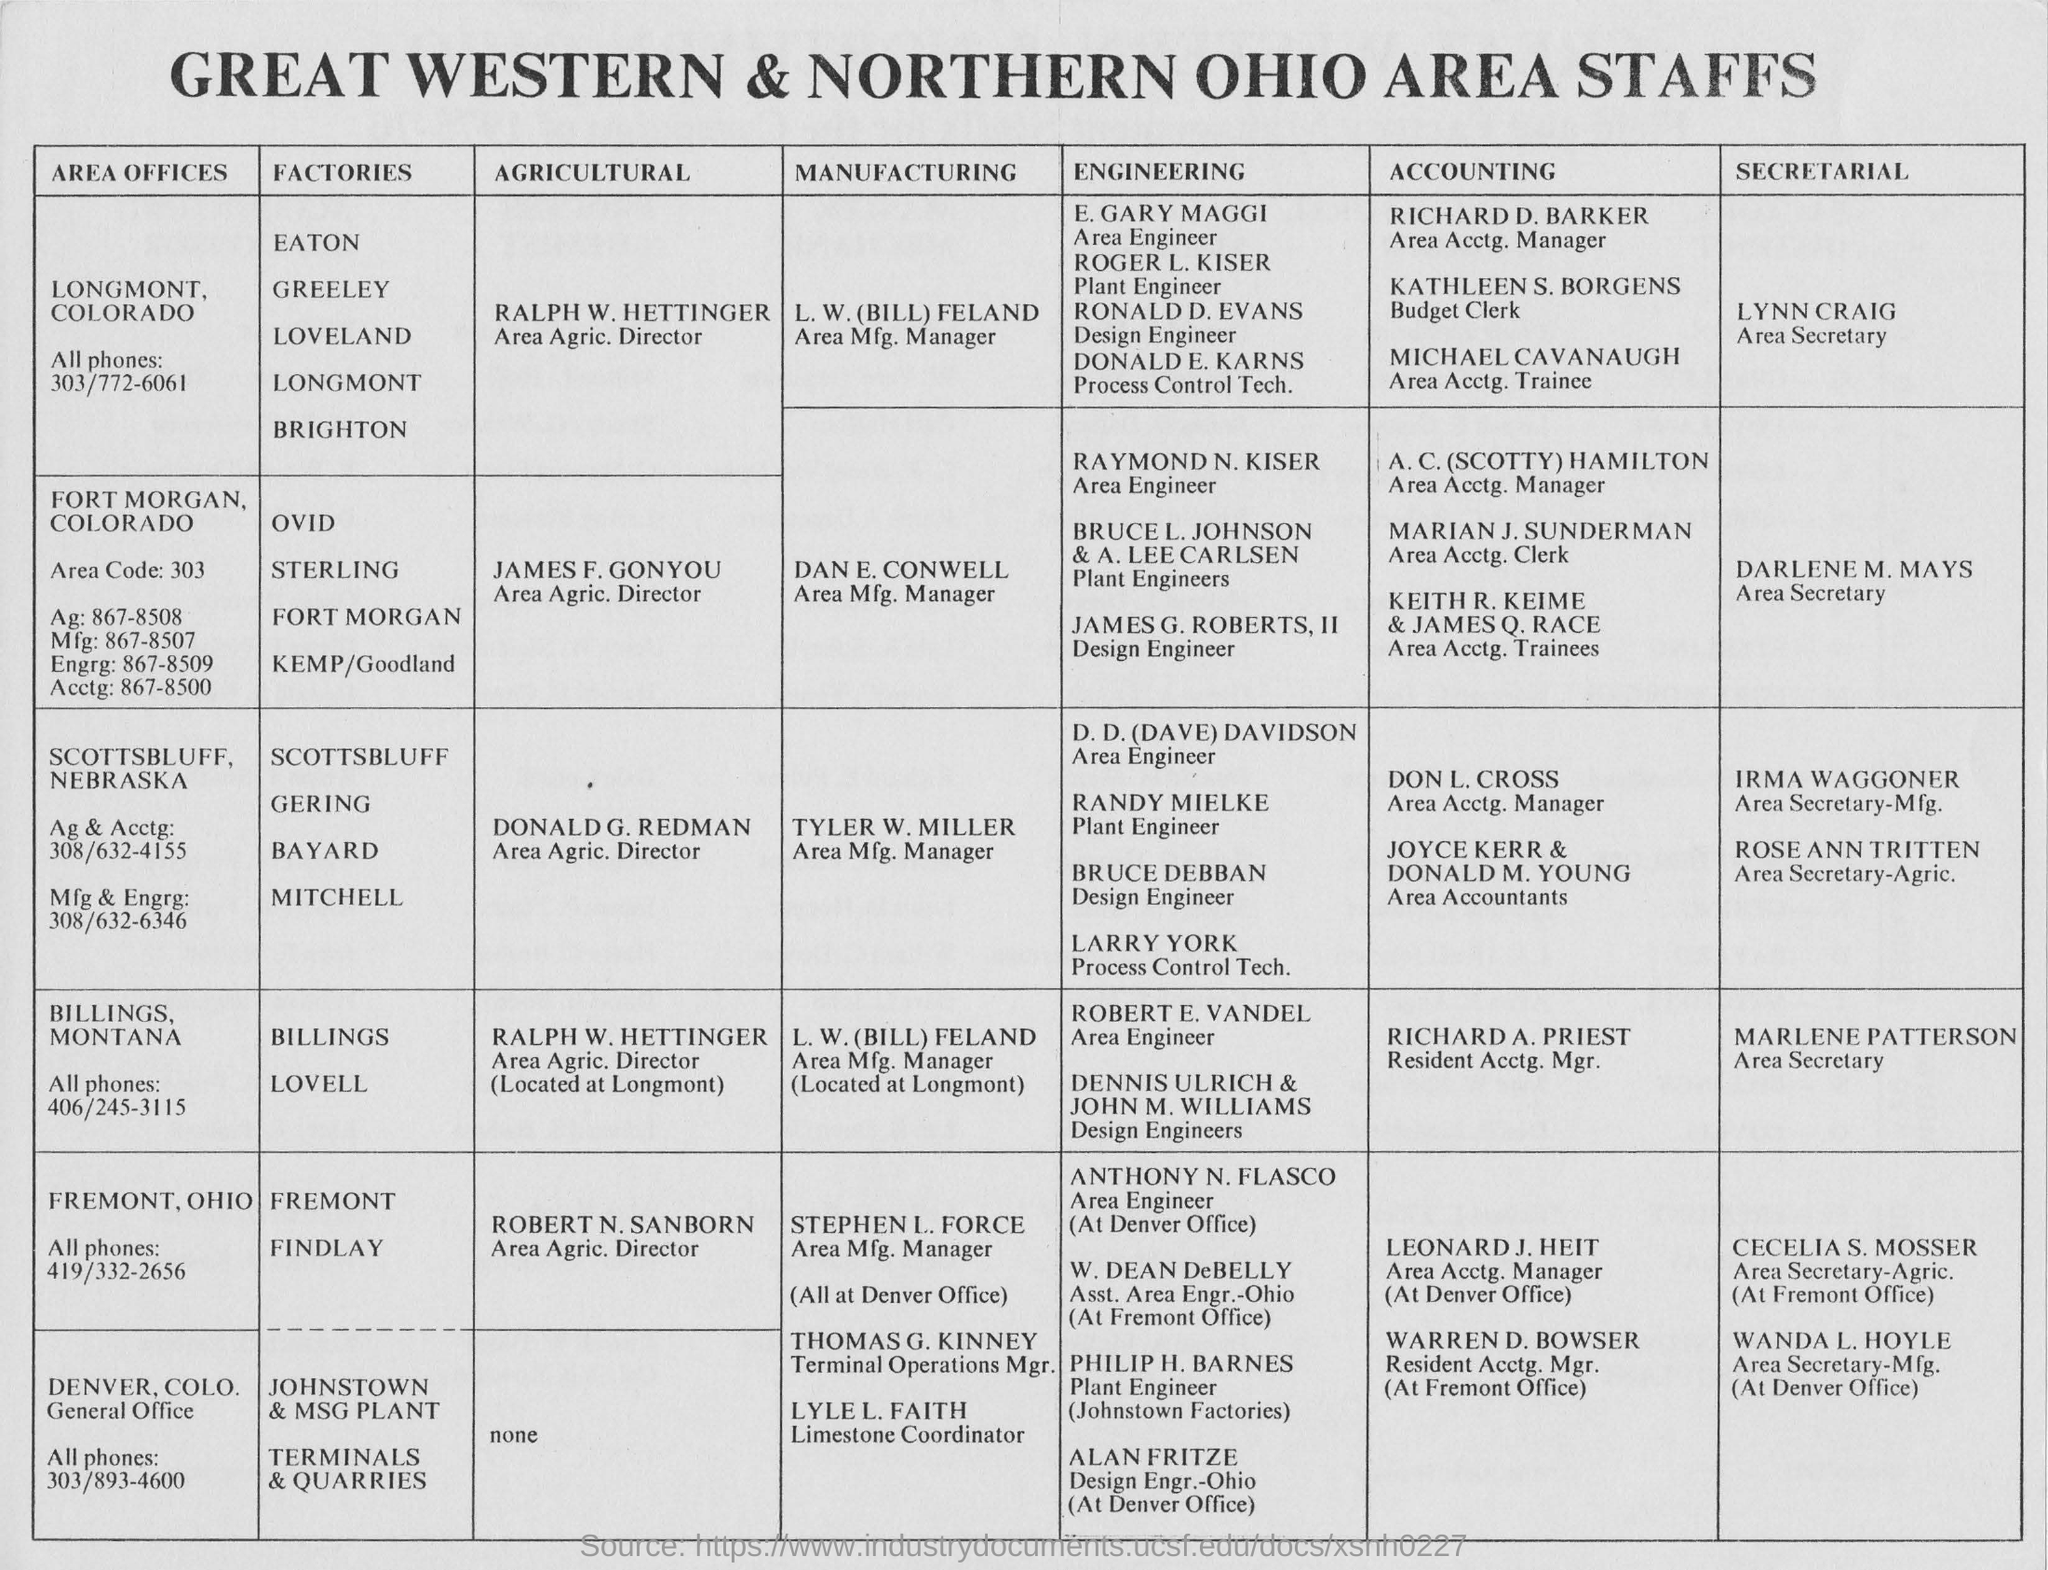Who are the people in the document?
Your answer should be compact. Great western & Northern Ohio Area Staffs. For which area is Lynn Craig the Area Secretary?
Provide a succinct answer. LONGMONT, COLORADO. Who is the agricultural director for fremont, ohio?
Your response must be concise. Robert N Sanborn. 